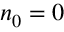Convert formula to latex. <formula><loc_0><loc_0><loc_500><loc_500>n _ { 0 } = 0</formula> 